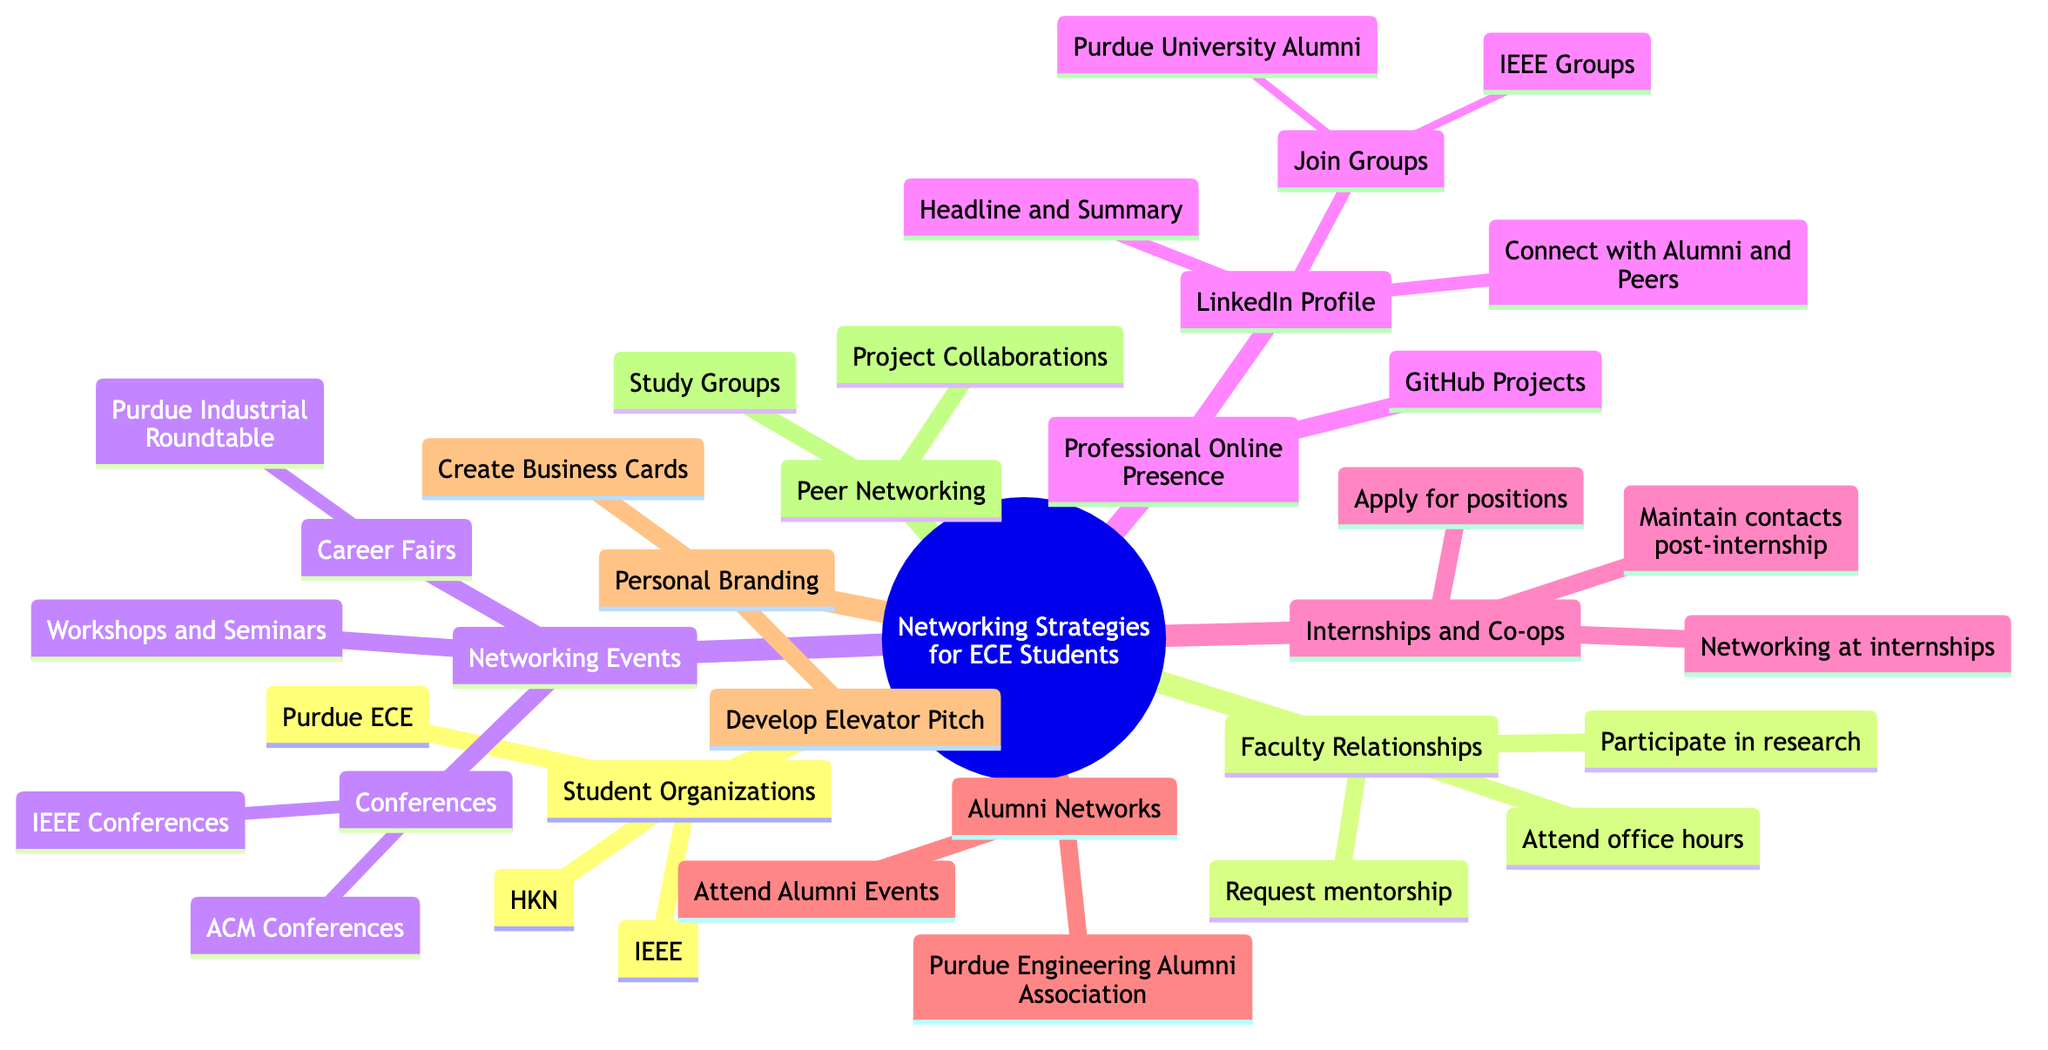What are the student organizations listed in the diagram? The diagram outlines three student organizations: IEEE, HKN, and Purdue ECE. These are explicitly named under the "Student Organizations" section.
Answer: IEEE, HKN, Purdue ECE How many types of networking events are mentioned in the diagram? The diagram lists three categories of networking events: Career Fairs, Conferences, and Workshops and Seminars. Thus, the total number is three.
Answer: 3 What is one way to build faculty relationships mentioned in the diagram? The diagram provides several methods for building faculty relationships, such as "Attend office hours," "Participate in research," and "Request mentorship," which indicates various actionable strategies.
Answer: Attend office hours Which online platform is recommended for professional online presence? The diagram specifically mentions LinkedIn Profile in the Professional Online Presence section, indicating its importance as a networking tool for ECE students.
Answer: LinkedIn Profile How many groups can be joined on LinkedIn according to the diagram? The diagram details two groups under the "Join Groups" section: Purdue University Alumni and IEEE Groups. Therefore, there are two groups mentioned for joining.
Answer: 2 What relationship exists between internships and networking? The diagram indicates that networking at internships is a strategy under the "Internships and Co-ops" section, which implies that internships can be a platform for building professional connections.
Answer: Networking at internships What type of events do alumni networks provide according to the diagram? The diagram states that Alumni Networks provide events listed as "Attend Alumni Events," indicating that alumni networks facilitate engagement through specific gatherings.
Answer: Attend Alumni Events What are two components of personal branding mentioned in the diagram? The components outlined in the diagram under Personal Branding are "Develop Elevator Pitch" and "Create Business Cards," which are essential for establishing a personal brand.
Answer: Develop Elevator Pitch, Create Business Cards How many types of relationships are outlined in the Faculty Relationships section? The diagram represents three distinct types of relationships or strategies for engagement with faculty, specifically enumerating "Attend office hours," "Participate in research," and "Request mentorship."
Answer: 3 